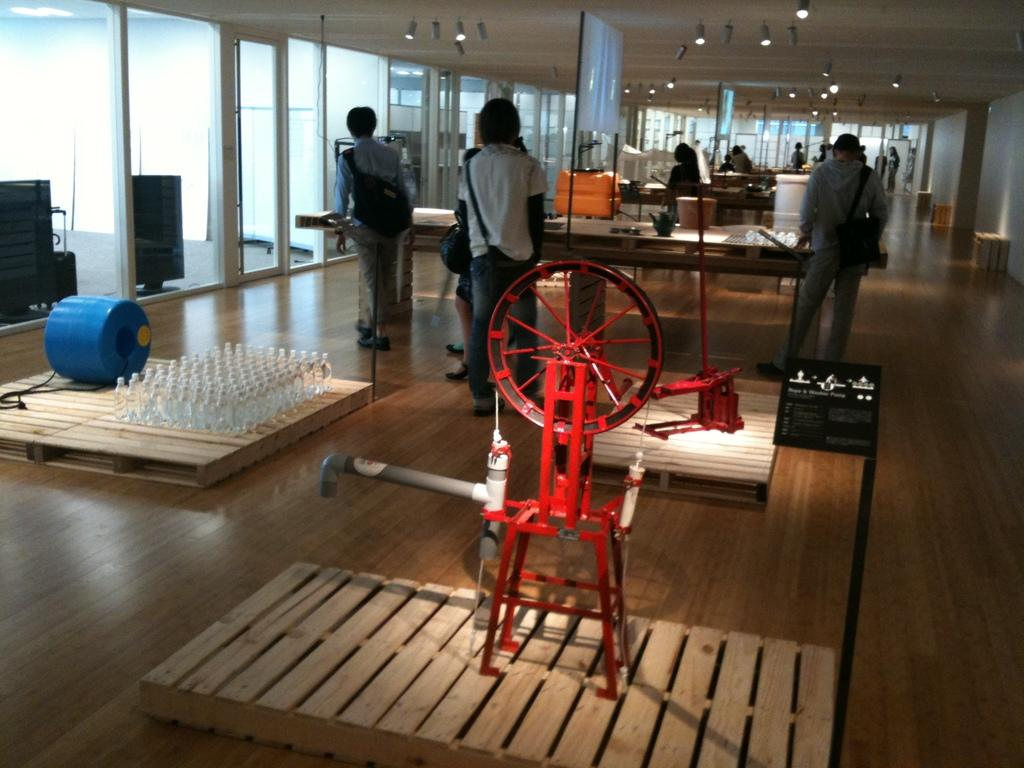What is happening in the image? There are people standing around a table in the image. Where might this scene be taking place? The location appears to be an art museum. What can be seen on the ceiling in the image? There are many lights on the ceiling in the image. How many knives are being used by the person in the image? There is no person using a knife in the image. What shape is the square object on the table in the image? There is no square object present on the table in the image. 